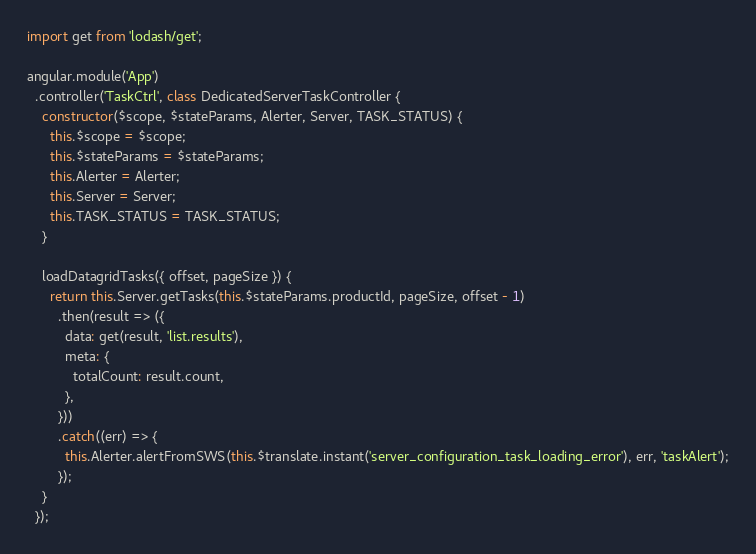Convert code to text. <code><loc_0><loc_0><loc_500><loc_500><_JavaScript_>import get from 'lodash/get';

angular.module('App')
  .controller('TaskCtrl', class DedicatedServerTaskController {
    constructor($scope, $stateParams, Alerter, Server, TASK_STATUS) {
      this.$scope = $scope;
      this.$stateParams = $stateParams;
      this.Alerter = Alerter;
      this.Server = Server;
      this.TASK_STATUS = TASK_STATUS;
    }

    loadDatagridTasks({ offset, pageSize }) {
      return this.Server.getTasks(this.$stateParams.productId, pageSize, offset - 1)
        .then(result => ({
          data: get(result, 'list.results'),
          meta: {
            totalCount: result.count,
          },
        }))
        .catch((err) => {
          this.Alerter.alertFromSWS(this.$translate.instant('server_configuration_task_loading_error'), err, 'taskAlert');
        });
    }
  });
</code> 